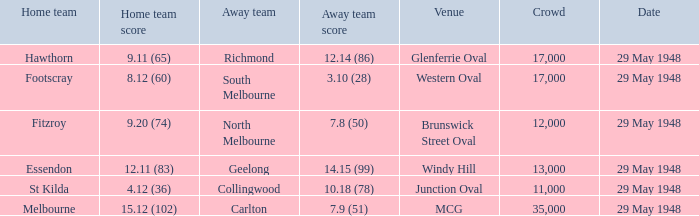In the contest with footscray as the home team, how many points did they achieve? 8.12 (60). 